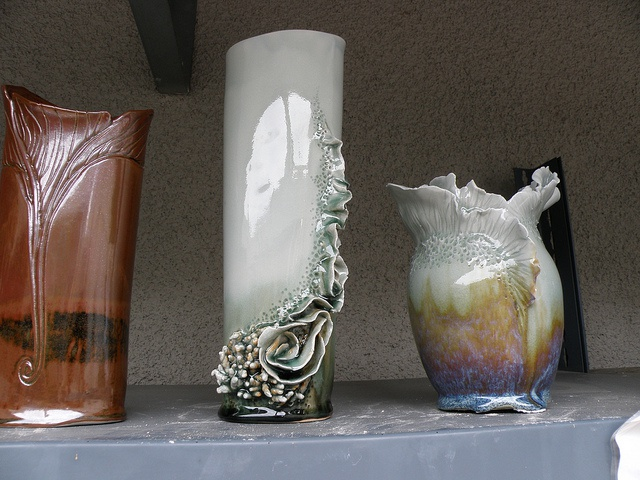Describe the objects in this image and their specific colors. I can see vase in black, darkgray, lightgray, and gray tones, vase in black, maroon, and gray tones, and vase in black, darkgray, gray, and lightgray tones in this image. 